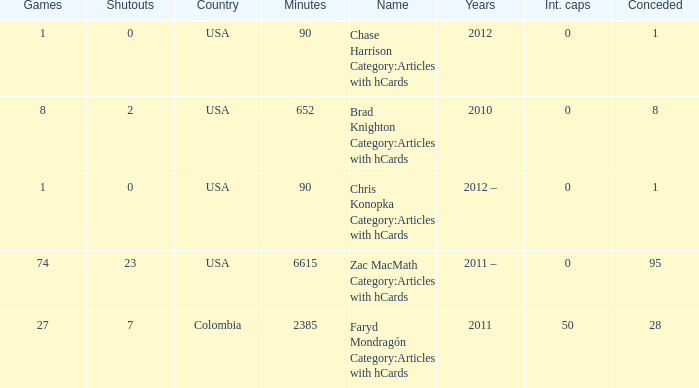When 2010 is the year what is the game? 8.0. 